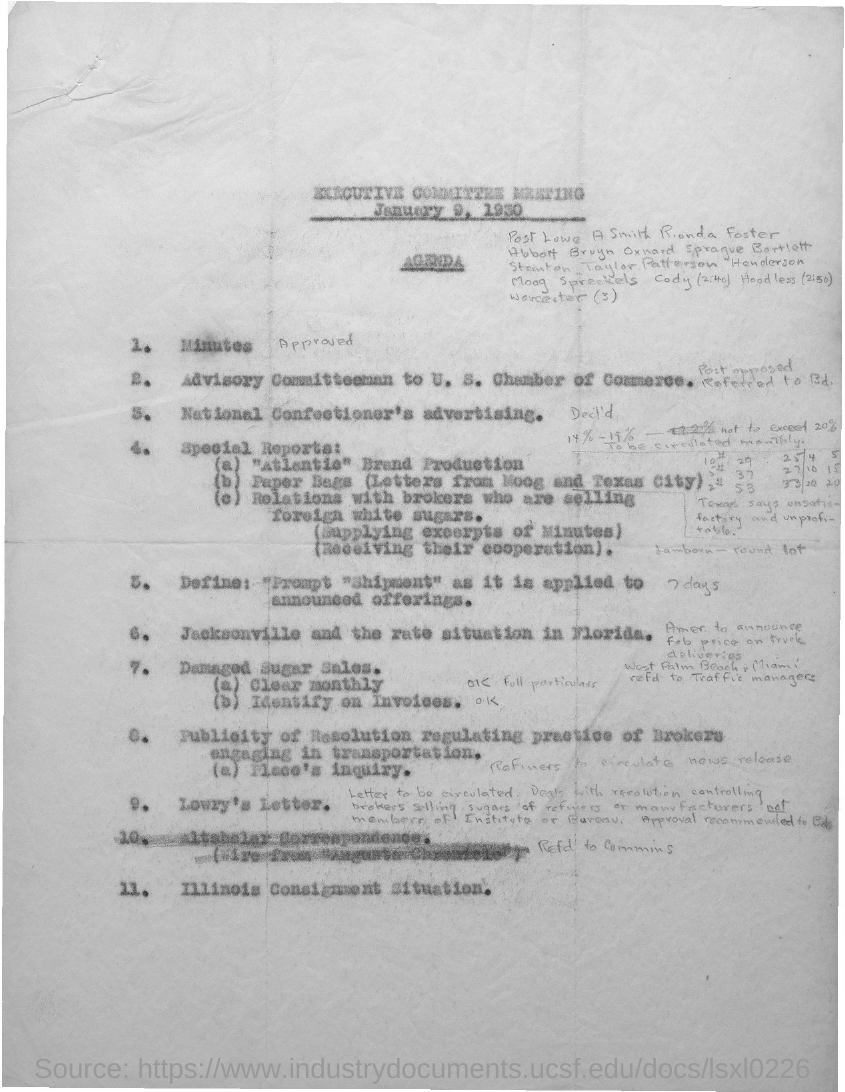Outline some significant characteristics in this image. The executive committee meeting is held on January 9, 1930. 